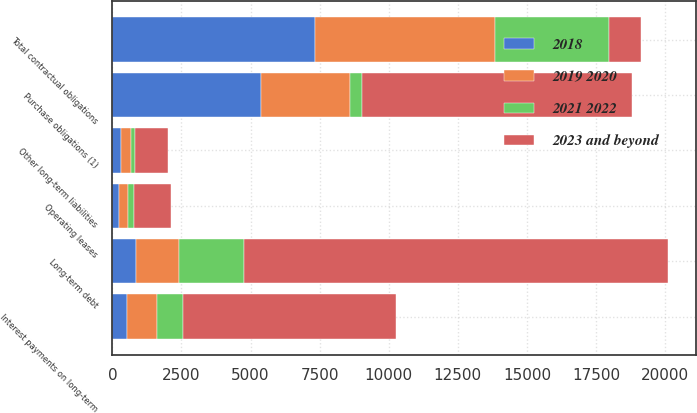Convert chart to OTSL. <chart><loc_0><loc_0><loc_500><loc_500><stacked_bar_chart><ecel><fcel>Long-term debt<fcel>Interest payments on long-term<fcel>Operating leases<fcel>Purchase obligations (1)<fcel>Other long-term liabilities<fcel>Total contractual obligations<nl><fcel>2023 and beyond<fcel>15350<fcel>7705<fcel>1338<fcel>9772<fcel>1187<fcel>1187<nl><fcel>2018<fcel>867<fcel>530<fcel>232<fcel>5396<fcel>302<fcel>7327<nl><fcel>2019 2020<fcel>1563<fcel>1069<fcel>340<fcel>3187<fcel>376<fcel>6535<nl><fcel>2021 2022<fcel>2339<fcel>955<fcel>207<fcel>458<fcel>132<fcel>4091<nl></chart> 